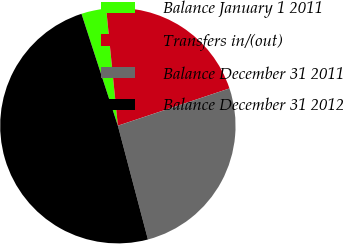Convert chart to OTSL. <chart><loc_0><loc_0><loc_500><loc_500><pie_chart><fcel>Balance January 1 2011<fcel>Transfers in/(out)<fcel>Balance December 31 2011<fcel>Balance December 31 2012<nl><fcel>3.42%<fcel>21.45%<fcel>26.02%<fcel>49.11%<nl></chart> 